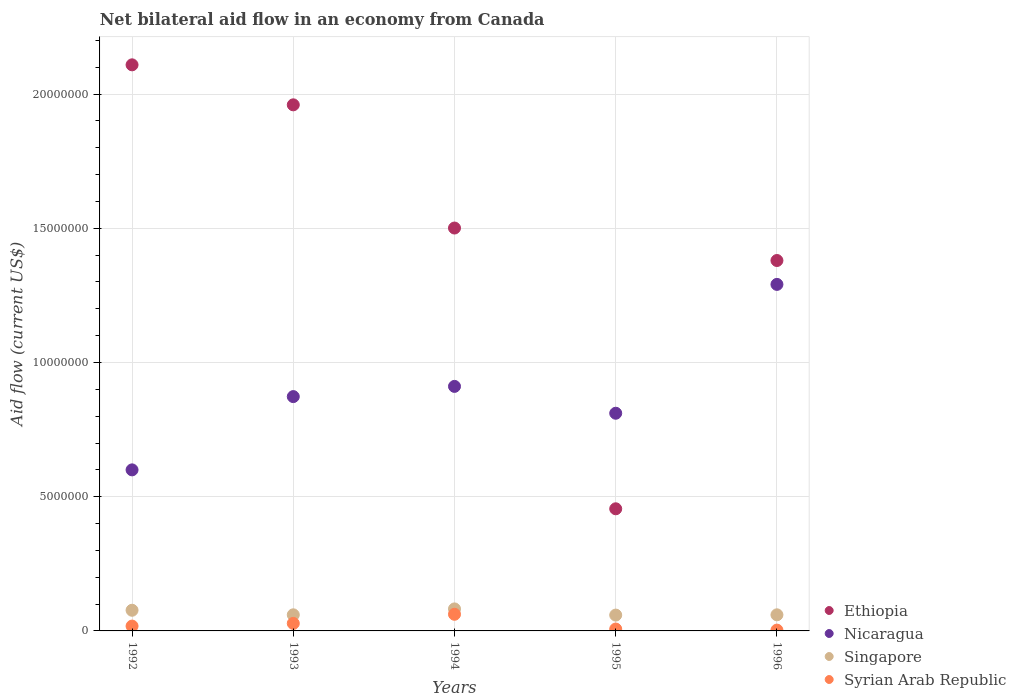How many different coloured dotlines are there?
Your response must be concise. 4. Is the number of dotlines equal to the number of legend labels?
Your response must be concise. Yes. What is the net bilateral aid flow in Ethiopia in 1996?
Keep it short and to the point. 1.38e+07. Across all years, what is the maximum net bilateral aid flow in Singapore?
Offer a very short reply. 8.20e+05. Across all years, what is the minimum net bilateral aid flow in Ethiopia?
Make the answer very short. 4.55e+06. In which year was the net bilateral aid flow in Syrian Arab Republic maximum?
Your answer should be very brief. 1994. What is the total net bilateral aid flow in Ethiopia in the graph?
Provide a succinct answer. 7.40e+07. What is the difference between the net bilateral aid flow in Singapore in 1994 and that in 1996?
Provide a succinct answer. 2.20e+05. What is the difference between the net bilateral aid flow in Ethiopia in 1994 and the net bilateral aid flow in Syrian Arab Republic in 1996?
Provide a succinct answer. 1.50e+07. What is the average net bilateral aid flow in Syrian Arab Republic per year?
Ensure brevity in your answer.  2.36e+05. In the year 1995, what is the difference between the net bilateral aid flow in Syrian Arab Republic and net bilateral aid flow in Singapore?
Give a very brief answer. -5.20e+05. In how many years, is the net bilateral aid flow in Singapore greater than 4000000 US$?
Your answer should be compact. 0. What is the ratio of the net bilateral aid flow in Ethiopia in 1992 to that in 1996?
Make the answer very short. 1.53. What is the difference between the highest and the second highest net bilateral aid flow in Syrian Arab Republic?
Provide a succinct answer. 3.40e+05. What is the difference between the highest and the lowest net bilateral aid flow in Syrian Arab Republic?
Give a very brief answer. 5.90e+05. In how many years, is the net bilateral aid flow in Nicaragua greater than the average net bilateral aid flow in Nicaragua taken over all years?
Give a very brief answer. 2. Is it the case that in every year, the sum of the net bilateral aid flow in Nicaragua and net bilateral aid flow in Syrian Arab Republic  is greater than the net bilateral aid flow in Ethiopia?
Your answer should be compact. No. Is the net bilateral aid flow in Syrian Arab Republic strictly greater than the net bilateral aid flow in Nicaragua over the years?
Offer a terse response. No. How many dotlines are there?
Provide a succinct answer. 4. What is the difference between two consecutive major ticks on the Y-axis?
Offer a terse response. 5.00e+06. Are the values on the major ticks of Y-axis written in scientific E-notation?
Provide a succinct answer. No. Does the graph contain grids?
Your answer should be very brief. Yes. How are the legend labels stacked?
Give a very brief answer. Vertical. What is the title of the graph?
Ensure brevity in your answer.  Net bilateral aid flow in an economy from Canada. What is the label or title of the X-axis?
Keep it short and to the point. Years. What is the Aid flow (current US$) of Ethiopia in 1992?
Offer a very short reply. 2.11e+07. What is the Aid flow (current US$) in Singapore in 1992?
Provide a succinct answer. 7.70e+05. What is the Aid flow (current US$) of Ethiopia in 1993?
Offer a very short reply. 1.96e+07. What is the Aid flow (current US$) in Nicaragua in 1993?
Make the answer very short. 8.73e+06. What is the Aid flow (current US$) of Syrian Arab Republic in 1993?
Provide a short and direct response. 2.80e+05. What is the Aid flow (current US$) in Ethiopia in 1994?
Your response must be concise. 1.50e+07. What is the Aid flow (current US$) in Nicaragua in 1994?
Offer a very short reply. 9.11e+06. What is the Aid flow (current US$) of Singapore in 1994?
Make the answer very short. 8.20e+05. What is the Aid flow (current US$) in Syrian Arab Republic in 1994?
Your answer should be very brief. 6.20e+05. What is the Aid flow (current US$) in Ethiopia in 1995?
Provide a succinct answer. 4.55e+06. What is the Aid flow (current US$) in Nicaragua in 1995?
Provide a short and direct response. 8.11e+06. What is the Aid flow (current US$) in Singapore in 1995?
Give a very brief answer. 5.90e+05. What is the Aid flow (current US$) in Ethiopia in 1996?
Make the answer very short. 1.38e+07. What is the Aid flow (current US$) in Nicaragua in 1996?
Your answer should be compact. 1.29e+07. Across all years, what is the maximum Aid flow (current US$) of Ethiopia?
Offer a very short reply. 2.11e+07. Across all years, what is the maximum Aid flow (current US$) of Nicaragua?
Offer a very short reply. 1.29e+07. Across all years, what is the maximum Aid flow (current US$) of Singapore?
Provide a short and direct response. 8.20e+05. Across all years, what is the maximum Aid flow (current US$) in Syrian Arab Republic?
Offer a terse response. 6.20e+05. Across all years, what is the minimum Aid flow (current US$) in Ethiopia?
Offer a very short reply. 4.55e+06. Across all years, what is the minimum Aid flow (current US$) in Nicaragua?
Your answer should be compact. 6.00e+06. Across all years, what is the minimum Aid flow (current US$) in Singapore?
Your response must be concise. 5.90e+05. Across all years, what is the minimum Aid flow (current US$) in Syrian Arab Republic?
Your answer should be very brief. 3.00e+04. What is the total Aid flow (current US$) of Ethiopia in the graph?
Ensure brevity in your answer.  7.40e+07. What is the total Aid flow (current US$) in Nicaragua in the graph?
Give a very brief answer. 4.49e+07. What is the total Aid flow (current US$) of Singapore in the graph?
Offer a very short reply. 3.38e+06. What is the total Aid flow (current US$) of Syrian Arab Republic in the graph?
Your answer should be compact. 1.18e+06. What is the difference between the Aid flow (current US$) in Ethiopia in 1992 and that in 1993?
Give a very brief answer. 1.49e+06. What is the difference between the Aid flow (current US$) of Nicaragua in 1992 and that in 1993?
Provide a succinct answer. -2.73e+06. What is the difference between the Aid flow (current US$) in Ethiopia in 1992 and that in 1994?
Make the answer very short. 6.08e+06. What is the difference between the Aid flow (current US$) of Nicaragua in 1992 and that in 1994?
Your response must be concise. -3.11e+06. What is the difference between the Aid flow (current US$) of Singapore in 1992 and that in 1994?
Your answer should be compact. -5.00e+04. What is the difference between the Aid flow (current US$) of Syrian Arab Republic in 1992 and that in 1994?
Provide a short and direct response. -4.40e+05. What is the difference between the Aid flow (current US$) of Ethiopia in 1992 and that in 1995?
Keep it short and to the point. 1.65e+07. What is the difference between the Aid flow (current US$) in Nicaragua in 1992 and that in 1995?
Provide a short and direct response. -2.11e+06. What is the difference between the Aid flow (current US$) in Singapore in 1992 and that in 1995?
Make the answer very short. 1.80e+05. What is the difference between the Aid flow (current US$) in Syrian Arab Republic in 1992 and that in 1995?
Make the answer very short. 1.10e+05. What is the difference between the Aid flow (current US$) of Ethiopia in 1992 and that in 1996?
Your answer should be compact. 7.29e+06. What is the difference between the Aid flow (current US$) of Nicaragua in 1992 and that in 1996?
Your response must be concise. -6.91e+06. What is the difference between the Aid flow (current US$) in Singapore in 1992 and that in 1996?
Provide a short and direct response. 1.70e+05. What is the difference between the Aid flow (current US$) in Ethiopia in 1993 and that in 1994?
Provide a succinct answer. 4.59e+06. What is the difference between the Aid flow (current US$) in Nicaragua in 1993 and that in 1994?
Your answer should be very brief. -3.80e+05. What is the difference between the Aid flow (current US$) of Singapore in 1993 and that in 1994?
Ensure brevity in your answer.  -2.20e+05. What is the difference between the Aid flow (current US$) in Ethiopia in 1993 and that in 1995?
Provide a short and direct response. 1.50e+07. What is the difference between the Aid flow (current US$) in Nicaragua in 1993 and that in 1995?
Your response must be concise. 6.20e+05. What is the difference between the Aid flow (current US$) of Syrian Arab Republic in 1993 and that in 1995?
Your answer should be compact. 2.10e+05. What is the difference between the Aid flow (current US$) in Ethiopia in 1993 and that in 1996?
Your answer should be compact. 5.80e+06. What is the difference between the Aid flow (current US$) of Nicaragua in 1993 and that in 1996?
Your response must be concise. -4.18e+06. What is the difference between the Aid flow (current US$) of Ethiopia in 1994 and that in 1995?
Provide a short and direct response. 1.05e+07. What is the difference between the Aid flow (current US$) in Singapore in 1994 and that in 1995?
Give a very brief answer. 2.30e+05. What is the difference between the Aid flow (current US$) of Syrian Arab Republic in 1994 and that in 1995?
Keep it short and to the point. 5.50e+05. What is the difference between the Aid flow (current US$) in Ethiopia in 1994 and that in 1996?
Offer a very short reply. 1.21e+06. What is the difference between the Aid flow (current US$) of Nicaragua in 1994 and that in 1996?
Make the answer very short. -3.80e+06. What is the difference between the Aid flow (current US$) of Singapore in 1994 and that in 1996?
Give a very brief answer. 2.20e+05. What is the difference between the Aid flow (current US$) in Syrian Arab Republic in 1994 and that in 1996?
Your response must be concise. 5.90e+05. What is the difference between the Aid flow (current US$) in Ethiopia in 1995 and that in 1996?
Offer a very short reply. -9.25e+06. What is the difference between the Aid flow (current US$) of Nicaragua in 1995 and that in 1996?
Keep it short and to the point. -4.80e+06. What is the difference between the Aid flow (current US$) of Ethiopia in 1992 and the Aid flow (current US$) of Nicaragua in 1993?
Offer a very short reply. 1.24e+07. What is the difference between the Aid flow (current US$) of Ethiopia in 1992 and the Aid flow (current US$) of Singapore in 1993?
Keep it short and to the point. 2.05e+07. What is the difference between the Aid flow (current US$) in Ethiopia in 1992 and the Aid flow (current US$) in Syrian Arab Republic in 1993?
Offer a very short reply. 2.08e+07. What is the difference between the Aid flow (current US$) in Nicaragua in 1992 and the Aid flow (current US$) in Singapore in 1993?
Keep it short and to the point. 5.40e+06. What is the difference between the Aid flow (current US$) of Nicaragua in 1992 and the Aid flow (current US$) of Syrian Arab Republic in 1993?
Offer a very short reply. 5.72e+06. What is the difference between the Aid flow (current US$) in Ethiopia in 1992 and the Aid flow (current US$) in Nicaragua in 1994?
Offer a terse response. 1.20e+07. What is the difference between the Aid flow (current US$) in Ethiopia in 1992 and the Aid flow (current US$) in Singapore in 1994?
Offer a terse response. 2.03e+07. What is the difference between the Aid flow (current US$) in Ethiopia in 1992 and the Aid flow (current US$) in Syrian Arab Republic in 1994?
Make the answer very short. 2.05e+07. What is the difference between the Aid flow (current US$) in Nicaragua in 1992 and the Aid flow (current US$) in Singapore in 1994?
Keep it short and to the point. 5.18e+06. What is the difference between the Aid flow (current US$) in Nicaragua in 1992 and the Aid flow (current US$) in Syrian Arab Republic in 1994?
Provide a succinct answer. 5.38e+06. What is the difference between the Aid flow (current US$) of Ethiopia in 1992 and the Aid flow (current US$) of Nicaragua in 1995?
Provide a succinct answer. 1.30e+07. What is the difference between the Aid flow (current US$) in Ethiopia in 1992 and the Aid flow (current US$) in Singapore in 1995?
Offer a very short reply. 2.05e+07. What is the difference between the Aid flow (current US$) in Ethiopia in 1992 and the Aid flow (current US$) in Syrian Arab Republic in 1995?
Offer a terse response. 2.10e+07. What is the difference between the Aid flow (current US$) in Nicaragua in 1992 and the Aid flow (current US$) in Singapore in 1995?
Provide a short and direct response. 5.41e+06. What is the difference between the Aid flow (current US$) in Nicaragua in 1992 and the Aid flow (current US$) in Syrian Arab Republic in 1995?
Ensure brevity in your answer.  5.93e+06. What is the difference between the Aid flow (current US$) of Singapore in 1992 and the Aid flow (current US$) of Syrian Arab Republic in 1995?
Give a very brief answer. 7.00e+05. What is the difference between the Aid flow (current US$) of Ethiopia in 1992 and the Aid flow (current US$) of Nicaragua in 1996?
Ensure brevity in your answer.  8.18e+06. What is the difference between the Aid flow (current US$) in Ethiopia in 1992 and the Aid flow (current US$) in Singapore in 1996?
Your response must be concise. 2.05e+07. What is the difference between the Aid flow (current US$) in Ethiopia in 1992 and the Aid flow (current US$) in Syrian Arab Republic in 1996?
Ensure brevity in your answer.  2.11e+07. What is the difference between the Aid flow (current US$) in Nicaragua in 1992 and the Aid flow (current US$) in Singapore in 1996?
Your response must be concise. 5.40e+06. What is the difference between the Aid flow (current US$) in Nicaragua in 1992 and the Aid flow (current US$) in Syrian Arab Republic in 1996?
Your response must be concise. 5.97e+06. What is the difference between the Aid flow (current US$) in Singapore in 1992 and the Aid flow (current US$) in Syrian Arab Republic in 1996?
Make the answer very short. 7.40e+05. What is the difference between the Aid flow (current US$) in Ethiopia in 1993 and the Aid flow (current US$) in Nicaragua in 1994?
Make the answer very short. 1.05e+07. What is the difference between the Aid flow (current US$) in Ethiopia in 1993 and the Aid flow (current US$) in Singapore in 1994?
Provide a succinct answer. 1.88e+07. What is the difference between the Aid flow (current US$) in Ethiopia in 1993 and the Aid flow (current US$) in Syrian Arab Republic in 1994?
Offer a terse response. 1.90e+07. What is the difference between the Aid flow (current US$) in Nicaragua in 1993 and the Aid flow (current US$) in Singapore in 1994?
Offer a terse response. 7.91e+06. What is the difference between the Aid flow (current US$) of Nicaragua in 1993 and the Aid flow (current US$) of Syrian Arab Republic in 1994?
Ensure brevity in your answer.  8.11e+06. What is the difference between the Aid flow (current US$) of Ethiopia in 1993 and the Aid flow (current US$) of Nicaragua in 1995?
Make the answer very short. 1.15e+07. What is the difference between the Aid flow (current US$) in Ethiopia in 1993 and the Aid flow (current US$) in Singapore in 1995?
Make the answer very short. 1.90e+07. What is the difference between the Aid flow (current US$) of Ethiopia in 1993 and the Aid flow (current US$) of Syrian Arab Republic in 1995?
Your answer should be very brief. 1.95e+07. What is the difference between the Aid flow (current US$) in Nicaragua in 1993 and the Aid flow (current US$) in Singapore in 1995?
Your response must be concise. 8.14e+06. What is the difference between the Aid flow (current US$) of Nicaragua in 1993 and the Aid flow (current US$) of Syrian Arab Republic in 1995?
Ensure brevity in your answer.  8.66e+06. What is the difference between the Aid flow (current US$) of Singapore in 1993 and the Aid flow (current US$) of Syrian Arab Republic in 1995?
Keep it short and to the point. 5.30e+05. What is the difference between the Aid flow (current US$) in Ethiopia in 1993 and the Aid flow (current US$) in Nicaragua in 1996?
Your answer should be compact. 6.69e+06. What is the difference between the Aid flow (current US$) of Ethiopia in 1993 and the Aid flow (current US$) of Singapore in 1996?
Provide a short and direct response. 1.90e+07. What is the difference between the Aid flow (current US$) of Ethiopia in 1993 and the Aid flow (current US$) of Syrian Arab Republic in 1996?
Ensure brevity in your answer.  1.96e+07. What is the difference between the Aid flow (current US$) of Nicaragua in 1993 and the Aid flow (current US$) of Singapore in 1996?
Provide a short and direct response. 8.13e+06. What is the difference between the Aid flow (current US$) in Nicaragua in 1993 and the Aid flow (current US$) in Syrian Arab Republic in 1996?
Your answer should be compact. 8.70e+06. What is the difference between the Aid flow (current US$) of Singapore in 1993 and the Aid flow (current US$) of Syrian Arab Republic in 1996?
Ensure brevity in your answer.  5.70e+05. What is the difference between the Aid flow (current US$) in Ethiopia in 1994 and the Aid flow (current US$) in Nicaragua in 1995?
Keep it short and to the point. 6.90e+06. What is the difference between the Aid flow (current US$) in Ethiopia in 1994 and the Aid flow (current US$) in Singapore in 1995?
Give a very brief answer. 1.44e+07. What is the difference between the Aid flow (current US$) of Ethiopia in 1994 and the Aid flow (current US$) of Syrian Arab Republic in 1995?
Your response must be concise. 1.49e+07. What is the difference between the Aid flow (current US$) of Nicaragua in 1994 and the Aid flow (current US$) of Singapore in 1995?
Give a very brief answer. 8.52e+06. What is the difference between the Aid flow (current US$) in Nicaragua in 1994 and the Aid flow (current US$) in Syrian Arab Republic in 1995?
Your answer should be very brief. 9.04e+06. What is the difference between the Aid flow (current US$) of Singapore in 1994 and the Aid flow (current US$) of Syrian Arab Republic in 1995?
Offer a very short reply. 7.50e+05. What is the difference between the Aid flow (current US$) of Ethiopia in 1994 and the Aid flow (current US$) of Nicaragua in 1996?
Offer a terse response. 2.10e+06. What is the difference between the Aid flow (current US$) of Ethiopia in 1994 and the Aid flow (current US$) of Singapore in 1996?
Provide a short and direct response. 1.44e+07. What is the difference between the Aid flow (current US$) of Ethiopia in 1994 and the Aid flow (current US$) of Syrian Arab Republic in 1996?
Provide a succinct answer. 1.50e+07. What is the difference between the Aid flow (current US$) of Nicaragua in 1994 and the Aid flow (current US$) of Singapore in 1996?
Offer a very short reply. 8.51e+06. What is the difference between the Aid flow (current US$) of Nicaragua in 1994 and the Aid flow (current US$) of Syrian Arab Republic in 1996?
Keep it short and to the point. 9.08e+06. What is the difference between the Aid flow (current US$) of Singapore in 1994 and the Aid flow (current US$) of Syrian Arab Republic in 1996?
Your response must be concise. 7.90e+05. What is the difference between the Aid flow (current US$) in Ethiopia in 1995 and the Aid flow (current US$) in Nicaragua in 1996?
Offer a very short reply. -8.36e+06. What is the difference between the Aid flow (current US$) of Ethiopia in 1995 and the Aid flow (current US$) of Singapore in 1996?
Give a very brief answer. 3.95e+06. What is the difference between the Aid flow (current US$) of Ethiopia in 1995 and the Aid flow (current US$) of Syrian Arab Republic in 1996?
Your response must be concise. 4.52e+06. What is the difference between the Aid flow (current US$) of Nicaragua in 1995 and the Aid flow (current US$) of Singapore in 1996?
Ensure brevity in your answer.  7.51e+06. What is the difference between the Aid flow (current US$) of Nicaragua in 1995 and the Aid flow (current US$) of Syrian Arab Republic in 1996?
Provide a succinct answer. 8.08e+06. What is the difference between the Aid flow (current US$) in Singapore in 1995 and the Aid flow (current US$) in Syrian Arab Republic in 1996?
Offer a terse response. 5.60e+05. What is the average Aid flow (current US$) in Ethiopia per year?
Your response must be concise. 1.48e+07. What is the average Aid flow (current US$) in Nicaragua per year?
Keep it short and to the point. 8.97e+06. What is the average Aid flow (current US$) in Singapore per year?
Give a very brief answer. 6.76e+05. What is the average Aid flow (current US$) of Syrian Arab Republic per year?
Provide a short and direct response. 2.36e+05. In the year 1992, what is the difference between the Aid flow (current US$) in Ethiopia and Aid flow (current US$) in Nicaragua?
Your answer should be very brief. 1.51e+07. In the year 1992, what is the difference between the Aid flow (current US$) of Ethiopia and Aid flow (current US$) of Singapore?
Offer a very short reply. 2.03e+07. In the year 1992, what is the difference between the Aid flow (current US$) of Ethiopia and Aid flow (current US$) of Syrian Arab Republic?
Keep it short and to the point. 2.09e+07. In the year 1992, what is the difference between the Aid flow (current US$) in Nicaragua and Aid flow (current US$) in Singapore?
Your answer should be very brief. 5.23e+06. In the year 1992, what is the difference between the Aid flow (current US$) in Nicaragua and Aid flow (current US$) in Syrian Arab Republic?
Your answer should be very brief. 5.82e+06. In the year 1992, what is the difference between the Aid flow (current US$) in Singapore and Aid flow (current US$) in Syrian Arab Republic?
Make the answer very short. 5.90e+05. In the year 1993, what is the difference between the Aid flow (current US$) of Ethiopia and Aid flow (current US$) of Nicaragua?
Provide a short and direct response. 1.09e+07. In the year 1993, what is the difference between the Aid flow (current US$) in Ethiopia and Aid flow (current US$) in Singapore?
Keep it short and to the point. 1.90e+07. In the year 1993, what is the difference between the Aid flow (current US$) in Ethiopia and Aid flow (current US$) in Syrian Arab Republic?
Keep it short and to the point. 1.93e+07. In the year 1993, what is the difference between the Aid flow (current US$) in Nicaragua and Aid flow (current US$) in Singapore?
Your answer should be compact. 8.13e+06. In the year 1993, what is the difference between the Aid flow (current US$) of Nicaragua and Aid flow (current US$) of Syrian Arab Republic?
Provide a short and direct response. 8.45e+06. In the year 1993, what is the difference between the Aid flow (current US$) of Singapore and Aid flow (current US$) of Syrian Arab Republic?
Your answer should be compact. 3.20e+05. In the year 1994, what is the difference between the Aid flow (current US$) in Ethiopia and Aid flow (current US$) in Nicaragua?
Offer a very short reply. 5.90e+06. In the year 1994, what is the difference between the Aid flow (current US$) of Ethiopia and Aid flow (current US$) of Singapore?
Give a very brief answer. 1.42e+07. In the year 1994, what is the difference between the Aid flow (current US$) in Ethiopia and Aid flow (current US$) in Syrian Arab Republic?
Your answer should be compact. 1.44e+07. In the year 1994, what is the difference between the Aid flow (current US$) in Nicaragua and Aid flow (current US$) in Singapore?
Provide a succinct answer. 8.29e+06. In the year 1994, what is the difference between the Aid flow (current US$) of Nicaragua and Aid flow (current US$) of Syrian Arab Republic?
Provide a short and direct response. 8.49e+06. In the year 1994, what is the difference between the Aid flow (current US$) in Singapore and Aid flow (current US$) in Syrian Arab Republic?
Provide a succinct answer. 2.00e+05. In the year 1995, what is the difference between the Aid flow (current US$) in Ethiopia and Aid flow (current US$) in Nicaragua?
Offer a very short reply. -3.56e+06. In the year 1995, what is the difference between the Aid flow (current US$) of Ethiopia and Aid flow (current US$) of Singapore?
Your answer should be very brief. 3.96e+06. In the year 1995, what is the difference between the Aid flow (current US$) in Ethiopia and Aid flow (current US$) in Syrian Arab Republic?
Offer a very short reply. 4.48e+06. In the year 1995, what is the difference between the Aid flow (current US$) of Nicaragua and Aid flow (current US$) of Singapore?
Provide a short and direct response. 7.52e+06. In the year 1995, what is the difference between the Aid flow (current US$) of Nicaragua and Aid flow (current US$) of Syrian Arab Republic?
Make the answer very short. 8.04e+06. In the year 1995, what is the difference between the Aid flow (current US$) of Singapore and Aid flow (current US$) of Syrian Arab Republic?
Offer a terse response. 5.20e+05. In the year 1996, what is the difference between the Aid flow (current US$) of Ethiopia and Aid flow (current US$) of Nicaragua?
Provide a short and direct response. 8.90e+05. In the year 1996, what is the difference between the Aid flow (current US$) of Ethiopia and Aid flow (current US$) of Singapore?
Make the answer very short. 1.32e+07. In the year 1996, what is the difference between the Aid flow (current US$) of Ethiopia and Aid flow (current US$) of Syrian Arab Republic?
Your answer should be compact. 1.38e+07. In the year 1996, what is the difference between the Aid flow (current US$) in Nicaragua and Aid flow (current US$) in Singapore?
Give a very brief answer. 1.23e+07. In the year 1996, what is the difference between the Aid flow (current US$) in Nicaragua and Aid flow (current US$) in Syrian Arab Republic?
Offer a terse response. 1.29e+07. In the year 1996, what is the difference between the Aid flow (current US$) of Singapore and Aid flow (current US$) of Syrian Arab Republic?
Provide a succinct answer. 5.70e+05. What is the ratio of the Aid flow (current US$) in Ethiopia in 1992 to that in 1993?
Your response must be concise. 1.08. What is the ratio of the Aid flow (current US$) in Nicaragua in 1992 to that in 1993?
Offer a very short reply. 0.69. What is the ratio of the Aid flow (current US$) in Singapore in 1992 to that in 1993?
Provide a short and direct response. 1.28. What is the ratio of the Aid flow (current US$) in Syrian Arab Republic in 1992 to that in 1993?
Keep it short and to the point. 0.64. What is the ratio of the Aid flow (current US$) of Ethiopia in 1992 to that in 1994?
Give a very brief answer. 1.41. What is the ratio of the Aid flow (current US$) in Nicaragua in 1992 to that in 1994?
Ensure brevity in your answer.  0.66. What is the ratio of the Aid flow (current US$) in Singapore in 1992 to that in 1994?
Your answer should be very brief. 0.94. What is the ratio of the Aid flow (current US$) of Syrian Arab Republic in 1992 to that in 1994?
Your response must be concise. 0.29. What is the ratio of the Aid flow (current US$) of Ethiopia in 1992 to that in 1995?
Offer a very short reply. 4.64. What is the ratio of the Aid flow (current US$) in Nicaragua in 1992 to that in 1995?
Ensure brevity in your answer.  0.74. What is the ratio of the Aid flow (current US$) of Singapore in 1992 to that in 1995?
Keep it short and to the point. 1.31. What is the ratio of the Aid flow (current US$) in Syrian Arab Republic in 1992 to that in 1995?
Keep it short and to the point. 2.57. What is the ratio of the Aid flow (current US$) of Ethiopia in 1992 to that in 1996?
Offer a very short reply. 1.53. What is the ratio of the Aid flow (current US$) of Nicaragua in 1992 to that in 1996?
Offer a very short reply. 0.46. What is the ratio of the Aid flow (current US$) in Singapore in 1992 to that in 1996?
Your response must be concise. 1.28. What is the ratio of the Aid flow (current US$) in Syrian Arab Republic in 1992 to that in 1996?
Keep it short and to the point. 6. What is the ratio of the Aid flow (current US$) in Ethiopia in 1993 to that in 1994?
Give a very brief answer. 1.31. What is the ratio of the Aid flow (current US$) of Singapore in 1993 to that in 1994?
Make the answer very short. 0.73. What is the ratio of the Aid flow (current US$) of Syrian Arab Republic in 1993 to that in 1994?
Offer a terse response. 0.45. What is the ratio of the Aid flow (current US$) in Ethiopia in 1993 to that in 1995?
Offer a very short reply. 4.31. What is the ratio of the Aid flow (current US$) of Nicaragua in 1993 to that in 1995?
Ensure brevity in your answer.  1.08. What is the ratio of the Aid flow (current US$) of Singapore in 1993 to that in 1995?
Make the answer very short. 1.02. What is the ratio of the Aid flow (current US$) in Syrian Arab Republic in 1993 to that in 1995?
Your answer should be very brief. 4. What is the ratio of the Aid flow (current US$) of Ethiopia in 1993 to that in 1996?
Make the answer very short. 1.42. What is the ratio of the Aid flow (current US$) in Nicaragua in 1993 to that in 1996?
Offer a very short reply. 0.68. What is the ratio of the Aid flow (current US$) of Singapore in 1993 to that in 1996?
Keep it short and to the point. 1. What is the ratio of the Aid flow (current US$) of Syrian Arab Republic in 1993 to that in 1996?
Provide a succinct answer. 9.33. What is the ratio of the Aid flow (current US$) in Ethiopia in 1994 to that in 1995?
Offer a terse response. 3.3. What is the ratio of the Aid flow (current US$) in Nicaragua in 1994 to that in 1995?
Offer a very short reply. 1.12. What is the ratio of the Aid flow (current US$) of Singapore in 1994 to that in 1995?
Provide a succinct answer. 1.39. What is the ratio of the Aid flow (current US$) in Syrian Arab Republic in 1994 to that in 1995?
Ensure brevity in your answer.  8.86. What is the ratio of the Aid flow (current US$) of Ethiopia in 1994 to that in 1996?
Ensure brevity in your answer.  1.09. What is the ratio of the Aid flow (current US$) in Nicaragua in 1994 to that in 1996?
Make the answer very short. 0.71. What is the ratio of the Aid flow (current US$) of Singapore in 1994 to that in 1996?
Keep it short and to the point. 1.37. What is the ratio of the Aid flow (current US$) of Syrian Arab Republic in 1994 to that in 1996?
Give a very brief answer. 20.67. What is the ratio of the Aid flow (current US$) of Ethiopia in 1995 to that in 1996?
Keep it short and to the point. 0.33. What is the ratio of the Aid flow (current US$) in Nicaragua in 1995 to that in 1996?
Your answer should be compact. 0.63. What is the ratio of the Aid flow (current US$) in Singapore in 1995 to that in 1996?
Your answer should be compact. 0.98. What is the ratio of the Aid flow (current US$) in Syrian Arab Republic in 1995 to that in 1996?
Your answer should be very brief. 2.33. What is the difference between the highest and the second highest Aid flow (current US$) of Ethiopia?
Make the answer very short. 1.49e+06. What is the difference between the highest and the second highest Aid flow (current US$) of Nicaragua?
Offer a terse response. 3.80e+06. What is the difference between the highest and the second highest Aid flow (current US$) of Singapore?
Provide a short and direct response. 5.00e+04. What is the difference between the highest and the second highest Aid flow (current US$) in Syrian Arab Republic?
Offer a very short reply. 3.40e+05. What is the difference between the highest and the lowest Aid flow (current US$) in Ethiopia?
Offer a terse response. 1.65e+07. What is the difference between the highest and the lowest Aid flow (current US$) of Nicaragua?
Make the answer very short. 6.91e+06. What is the difference between the highest and the lowest Aid flow (current US$) in Singapore?
Your answer should be very brief. 2.30e+05. What is the difference between the highest and the lowest Aid flow (current US$) in Syrian Arab Republic?
Your response must be concise. 5.90e+05. 